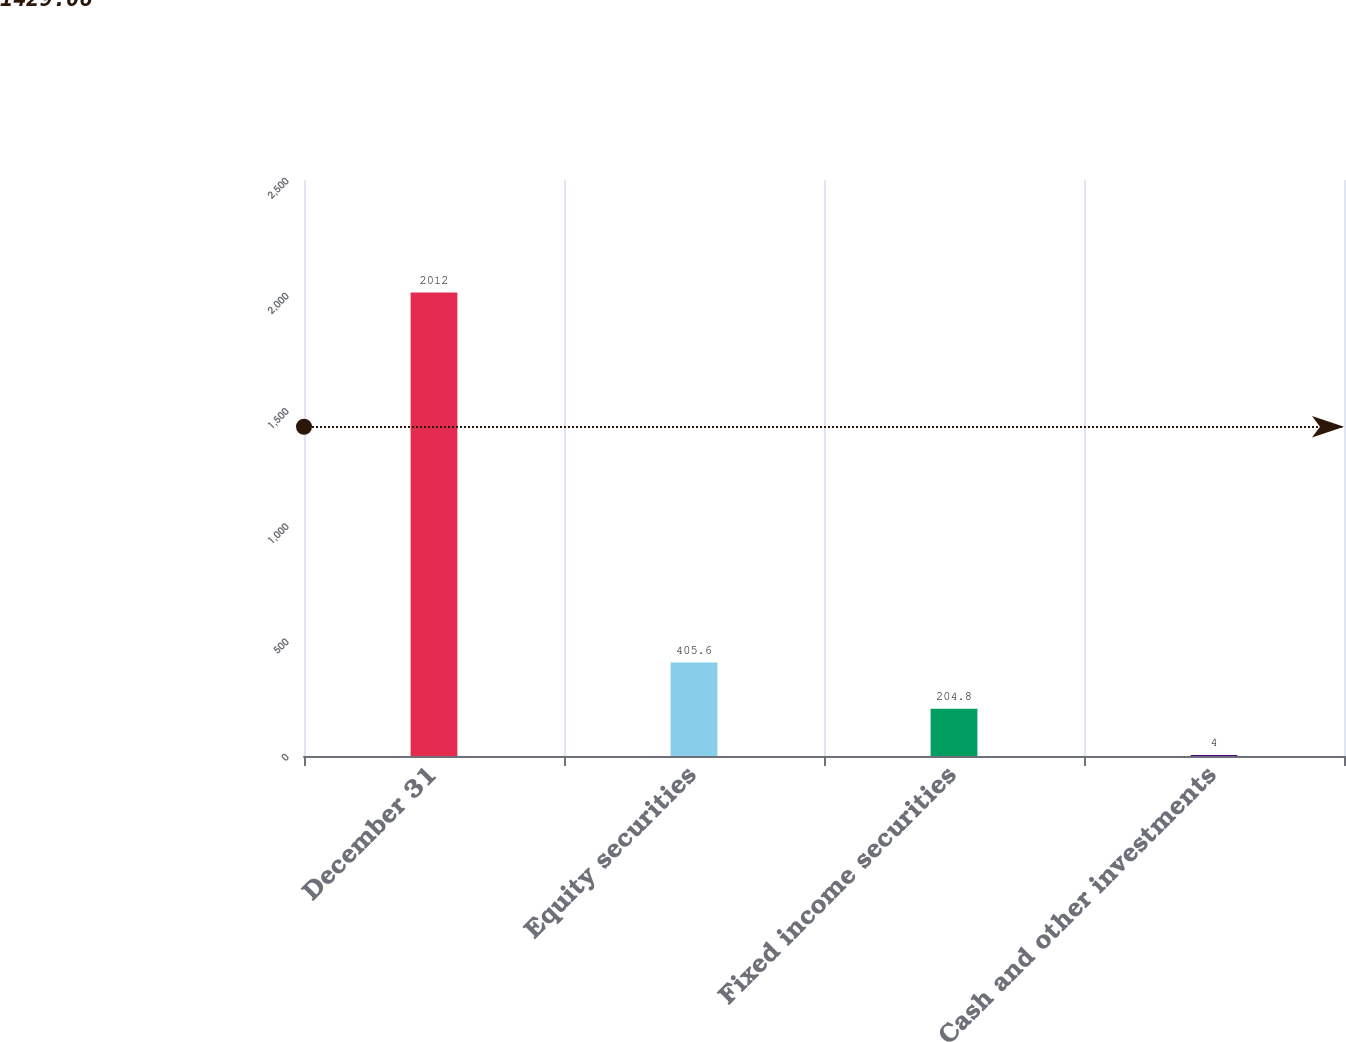Convert chart to OTSL. <chart><loc_0><loc_0><loc_500><loc_500><bar_chart><fcel>December 31<fcel>Equity securities<fcel>Fixed income securities<fcel>Cash and other investments<nl><fcel>2012<fcel>405.6<fcel>204.8<fcel>4<nl></chart> 